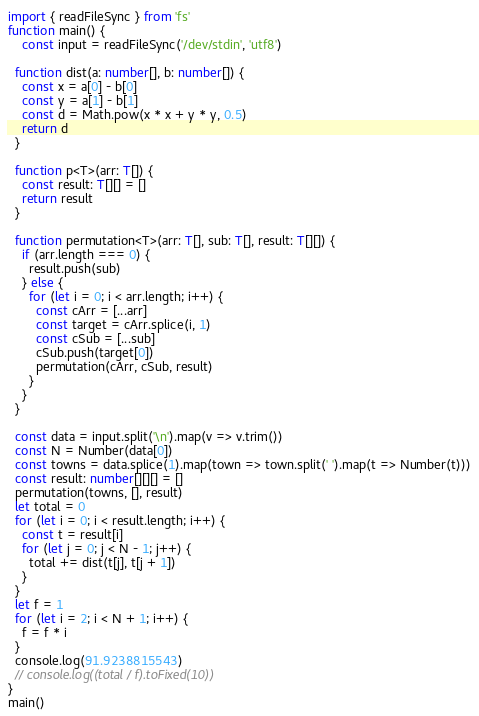Convert code to text. <code><loc_0><loc_0><loc_500><loc_500><_TypeScript_>import { readFileSync } from 'fs'
function main() {
	const input = readFileSync('/dev/stdin', 'utf8')

  function dist(a: number[], b: number[]) {
    const x = a[0] - b[0]
    const y = a[1] - b[1]
    const d = Math.pow(x * x + y * y, 0.5)
    return d
  }

  function p<T>(arr: T[]) {
    const result: T[][] = []
    return result
  }

  function permutation<T>(arr: T[], sub: T[], result: T[][]) {
    if (arr.length === 0) {
      result.push(sub)
    } else {
      for (let i = 0; i < arr.length; i++) {
        const cArr = [...arr]
        const target = cArr.splice(i, 1)
        const cSub = [...sub]
        cSub.push(target[0])
        permutation(cArr, cSub, result)        
      }
    }
  }

  const data = input.split('\n').map(v => v.trim())
  const N = Number(data[0])
  const towns = data.splice(1).map(town => town.split(' ').map(t => Number(t)))
  const result: number[][][] = []
  permutation(towns, [], result)
  let total = 0
  for (let i = 0; i < result.length; i++) {
    const t = result[i]
    for (let j = 0; j < N - 1; j++) {
      total += dist(t[j], t[j + 1])      
    }
  }
  let f = 1
  for (let i = 2; i < N + 1; i++) {
    f = f * i
  }
  console.log(91.9238815543)
  // console.log((total / f).toFixed(10))
}
main()
</code> 